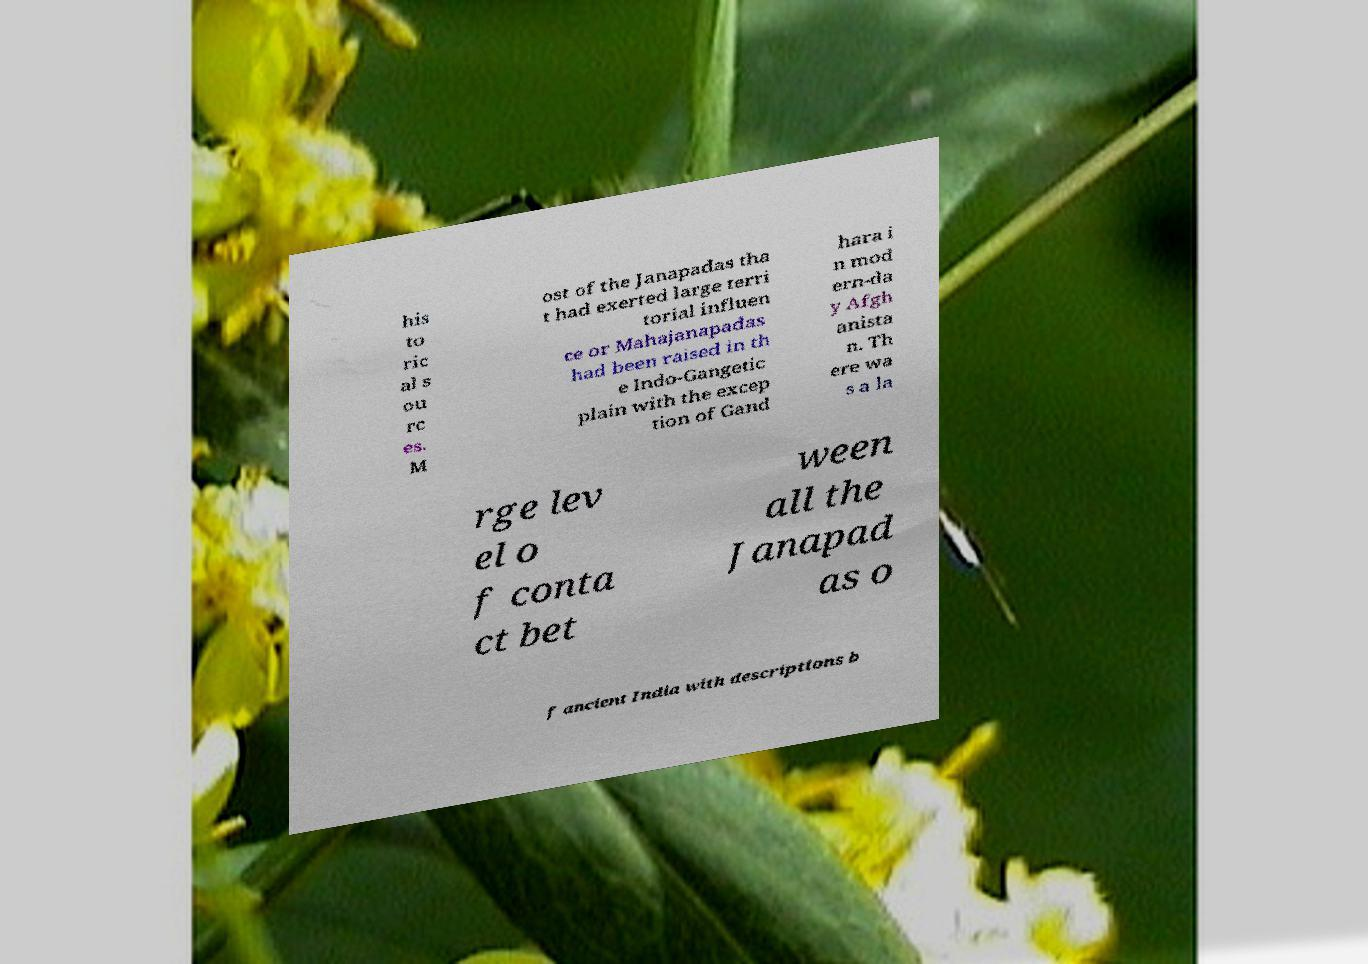I need the written content from this picture converted into text. Can you do that? his to ric al s ou rc es. M ost of the Janapadas tha t had exerted large terri torial influen ce or Mahajanapadas had been raised in th e Indo-Gangetic plain with the excep tion of Gand hara i n mod ern-da y Afgh anista n. Th ere wa s a la rge lev el o f conta ct bet ween all the Janapad as o f ancient India with descriptions b 